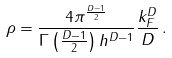<formula> <loc_0><loc_0><loc_500><loc_500>\rho = \frac { 4 \pi ^ { \frac { D - 1 } { 2 } } } { \Gamma \left ( \frac { D - 1 } { 2 } \right ) h ^ { D - 1 } } \frac { k _ { F } ^ { D } } { D } \, .</formula> 